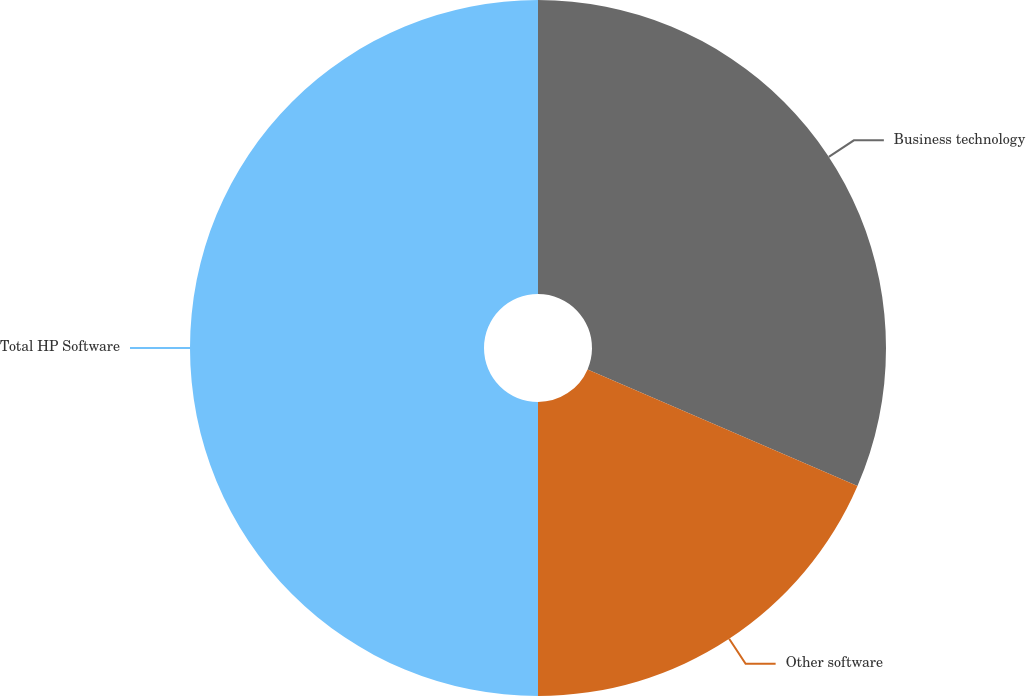Convert chart to OTSL. <chart><loc_0><loc_0><loc_500><loc_500><pie_chart><fcel>Business technology<fcel>Other software<fcel>Total HP Software<nl><fcel>31.49%<fcel>18.51%<fcel>50.0%<nl></chart> 